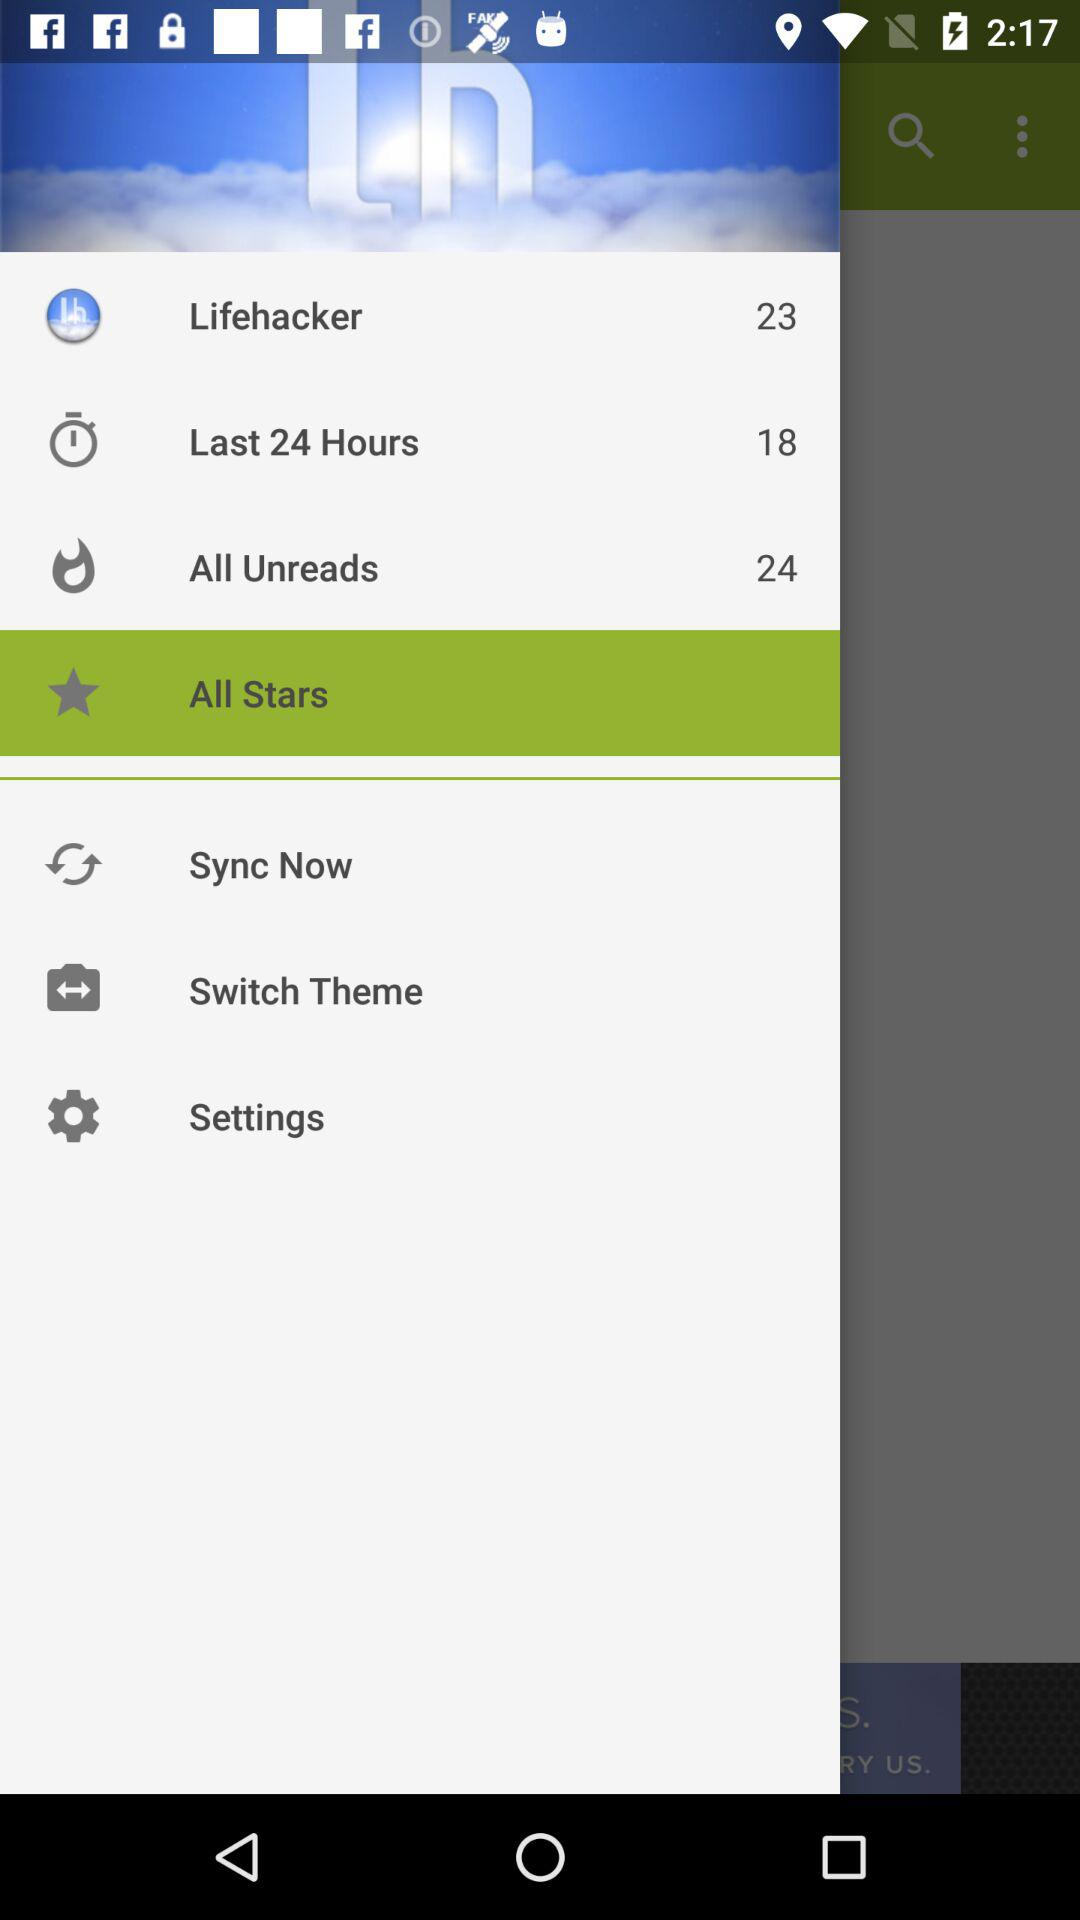What is the count of "All Unreads"? The count is 24. 